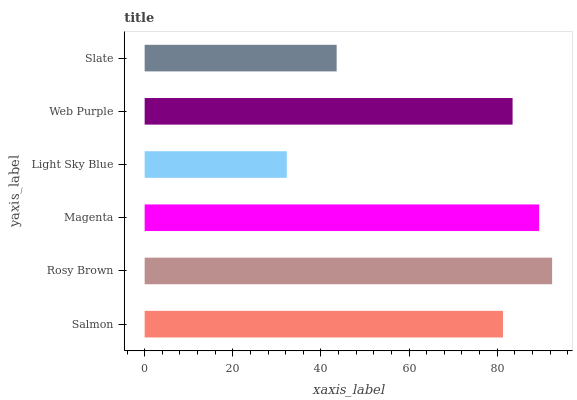Is Light Sky Blue the minimum?
Answer yes or no. Yes. Is Rosy Brown the maximum?
Answer yes or no. Yes. Is Magenta the minimum?
Answer yes or no. No. Is Magenta the maximum?
Answer yes or no. No. Is Rosy Brown greater than Magenta?
Answer yes or no. Yes. Is Magenta less than Rosy Brown?
Answer yes or no. Yes. Is Magenta greater than Rosy Brown?
Answer yes or no. No. Is Rosy Brown less than Magenta?
Answer yes or no. No. Is Web Purple the high median?
Answer yes or no. Yes. Is Salmon the low median?
Answer yes or no. Yes. Is Salmon the high median?
Answer yes or no. No. Is Light Sky Blue the low median?
Answer yes or no. No. 